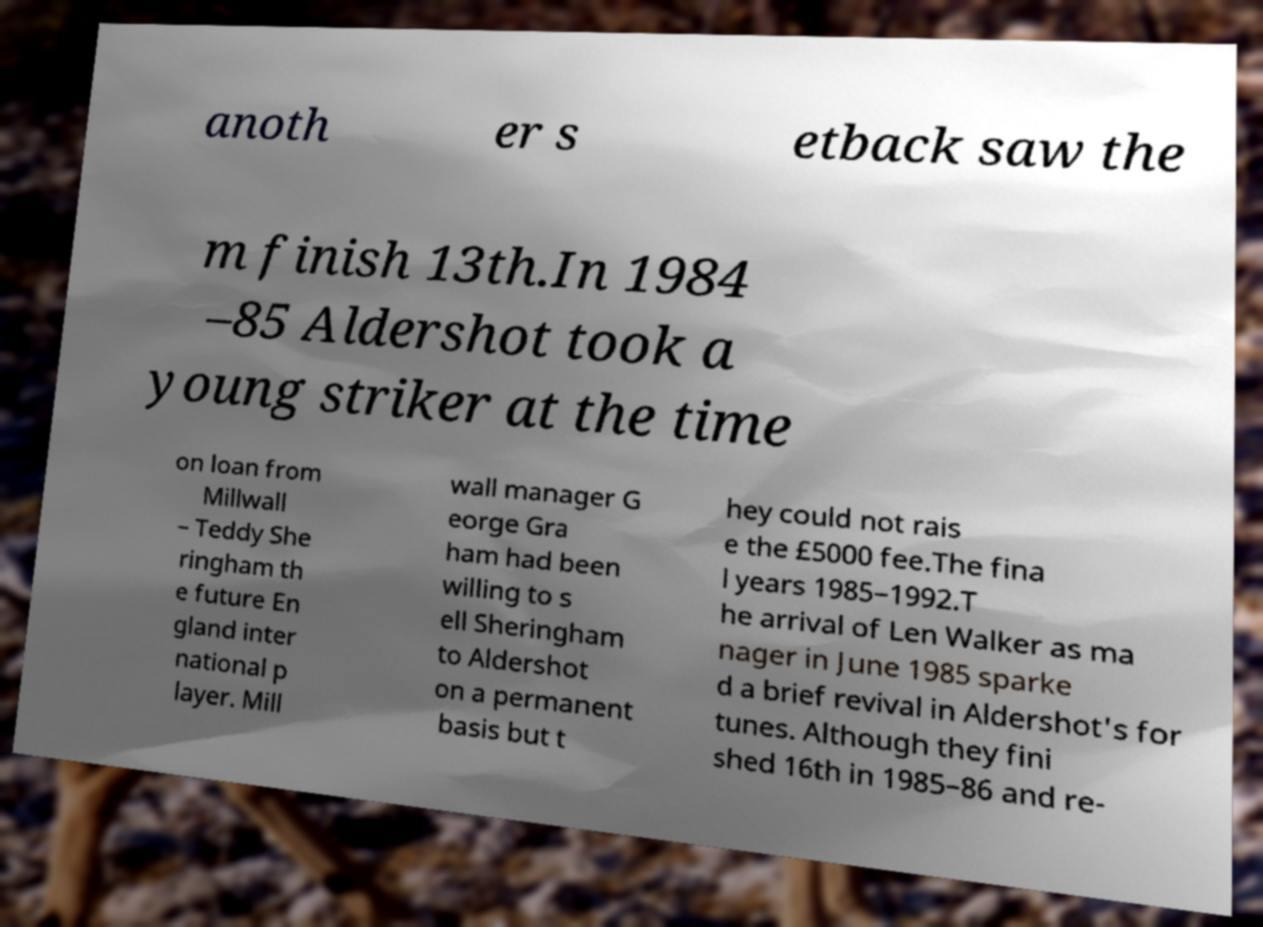Could you assist in decoding the text presented in this image and type it out clearly? anoth er s etback saw the m finish 13th.In 1984 –85 Aldershot took a young striker at the time on loan from Millwall – Teddy She ringham th e future En gland inter national p layer. Mill wall manager G eorge Gra ham had been willing to s ell Sheringham to Aldershot on a permanent basis but t hey could not rais e the £5000 fee.The fina l years 1985–1992.T he arrival of Len Walker as ma nager in June 1985 sparke d a brief revival in Aldershot's for tunes. Although they fini shed 16th in 1985–86 and re- 